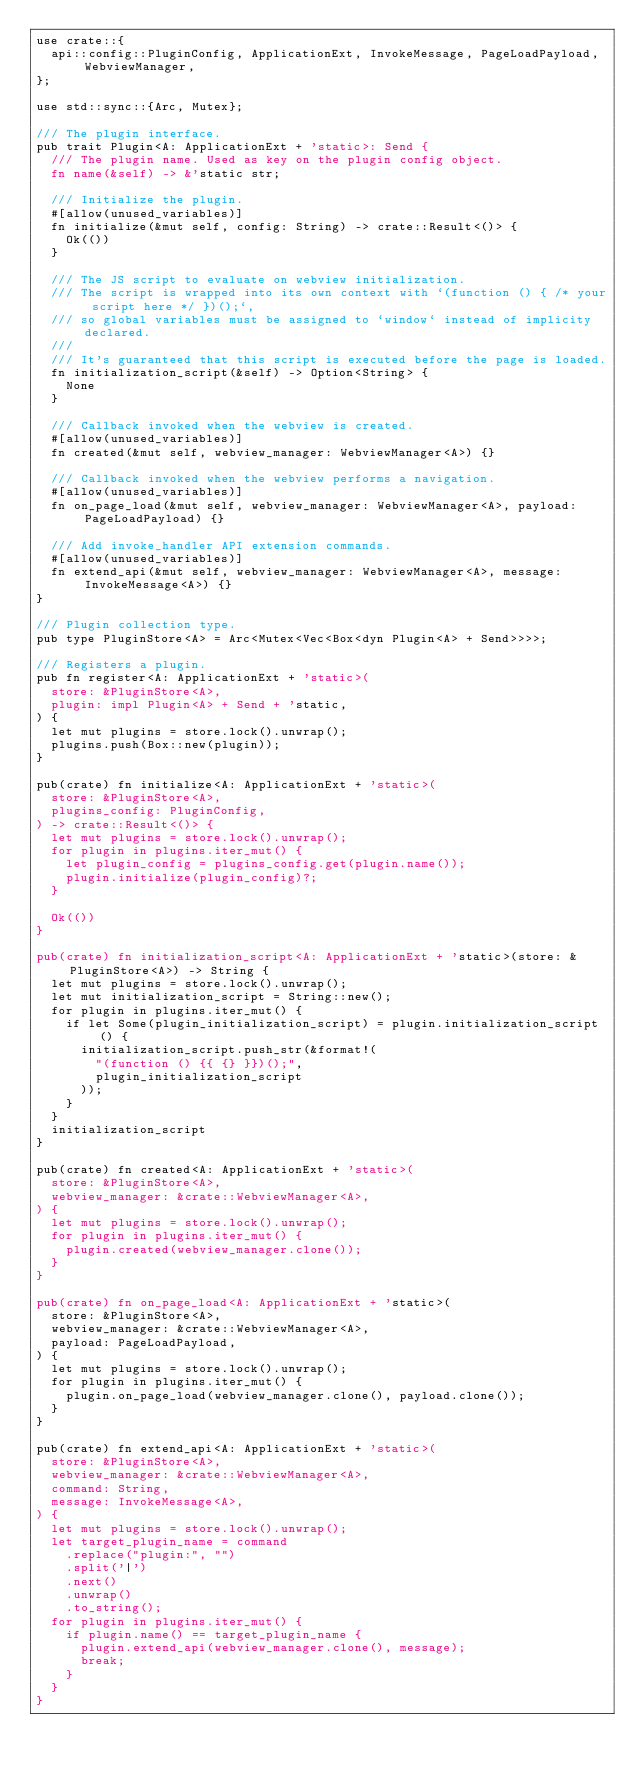<code> <loc_0><loc_0><loc_500><loc_500><_Rust_>use crate::{
  api::config::PluginConfig, ApplicationExt, InvokeMessage, PageLoadPayload, WebviewManager,
};

use std::sync::{Arc, Mutex};

/// The plugin interface.
pub trait Plugin<A: ApplicationExt + 'static>: Send {
  /// The plugin name. Used as key on the plugin config object.
  fn name(&self) -> &'static str;

  /// Initialize the plugin.
  #[allow(unused_variables)]
  fn initialize(&mut self, config: String) -> crate::Result<()> {
    Ok(())
  }

  /// The JS script to evaluate on webview initialization.
  /// The script is wrapped into its own context with `(function () { /* your script here */ })();`,
  /// so global variables must be assigned to `window` instead of implicity declared.
  ///
  /// It's guaranteed that this script is executed before the page is loaded.
  fn initialization_script(&self) -> Option<String> {
    None
  }

  /// Callback invoked when the webview is created.
  #[allow(unused_variables)]
  fn created(&mut self, webview_manager: WebviewManager<A>) {}

  /// Callback invoked when the webview performs a navigation.
  #[allow(unused_variables)]
  fn on_page_load(&mut self, webview_manager: WebviewManager<A>, payload: PageLoadPayload) {}

  /// Add invoke_handler API extension commands.
  #[allow(unused_variables)]
  fn extend_api(&mut self, webview_manager: WebviewManager<A>, message: InvokeMessage<A>) {}
}

/// Plugin collection type.
pub type PluginStore<A> = Arc<Mutex<Vec<Box<dyn Plugin<A> + Send>>>>;

/// Registers a plugin.
pub fn register<A: ApplicationExt + 'static>(
  store: &PluginStore<A>,
  plugin: impl Plugin<A> + Send + 'static,
) {
  let mut plugins = store.lock().unwrap();
  plugins.push(Box::new(plugin));
}

pub(crate) fn initialize<A: ApplicationExt + 'static>(
  store: &PluginStore<A>,
  plugins_config: PluginConfig,
) -> crate::Result<()> {
  let mut plugins = store.lock().unwrap();
  for plugin in plugins.iter_mut() {
    let plugin_config = plugins_config.get(plugin.name());
    plugin.initialize(plugin_config)?;
  }

  Ok(())
}

pub(crate) fn initialization_script<A: ApplicationExt + 'static>(store: &PluginStore<A>) -> String {
  let mut plugins = store.lock().unwrap();
  let mut initialization_script = String::new();
  for plugin in plugins.iter_mut() {
    if let Some(plugin_initialization_script) = plugin.initialization_script() {
      initialization_script.push_str(&format!(
        "(function () {{ {} }})();",
        plugin_initialization_script
      ));
    }
  }
  initialization_script
}

pub(crate) fn created<A: ApplicationExt + 'static>(
  store: &PluginStore<A>,
  webview_manager: &crate::WebviewManager<A>,
) {
  let mut plugins = store.lock().unwrap();
  for plugin in plugins.iter_mut() {
    plugin.created(webview_manager.clone());
  }
}

pub(crate) fn on_page_load<A: ApplicationExt + 'static>(
  store: &PluginStore<A>,
  webview_manager: &crate::WebviewManager<A>,
  payload: PageLoadPayload,
) {
  let mut plugins = store.lock().unwrap();
  for plugin in plugins.iter_mut() {
    plugin.on_page_load(webview_manager.clone(), payload.clone());
  }
}

pub(crate) fn extend_api<A: ApplicationExt + 'static>(
  store: &PluginStore<A>,
  webview_manager: &crate::WebviewManager<A>,
  command: String,
  message: InvokeMessage<A>,
) {
  let mut plugins = store.lock().unwrap();
  let target_plugin_name = command
    .replace("plugin:", "")
    .split('|')
    .next()
    .unwrap()
    .to_string();
  for plugin in plugins.iter_mut() {
    if plugin.name() == target_plugin_name {
      plugin.extend_api(webview_manager.clone(), message);
      break;
    }
  }
}
</code> 